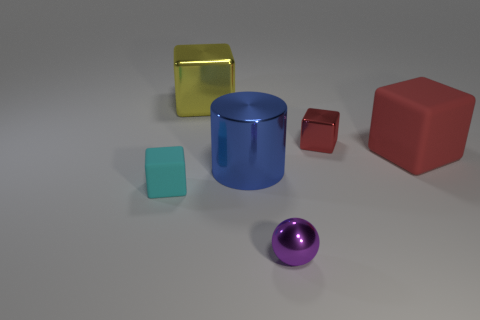Subtract all green blocks. Subtract all purple balls. How many blocks are left? 4 Add 1 red shiny things. How many objects exist? 7 Subtract all cubes. How many objects are left? 2 Add 3 big yellow things. How many big yellow things are left? 4 Add 2 red objects. How many red objects exist? 4 Subtract 1 cyan cubes. How many objects are left? 5 Subtract all rubber things. Subtract all big cylinders. How many objects are left? 3 